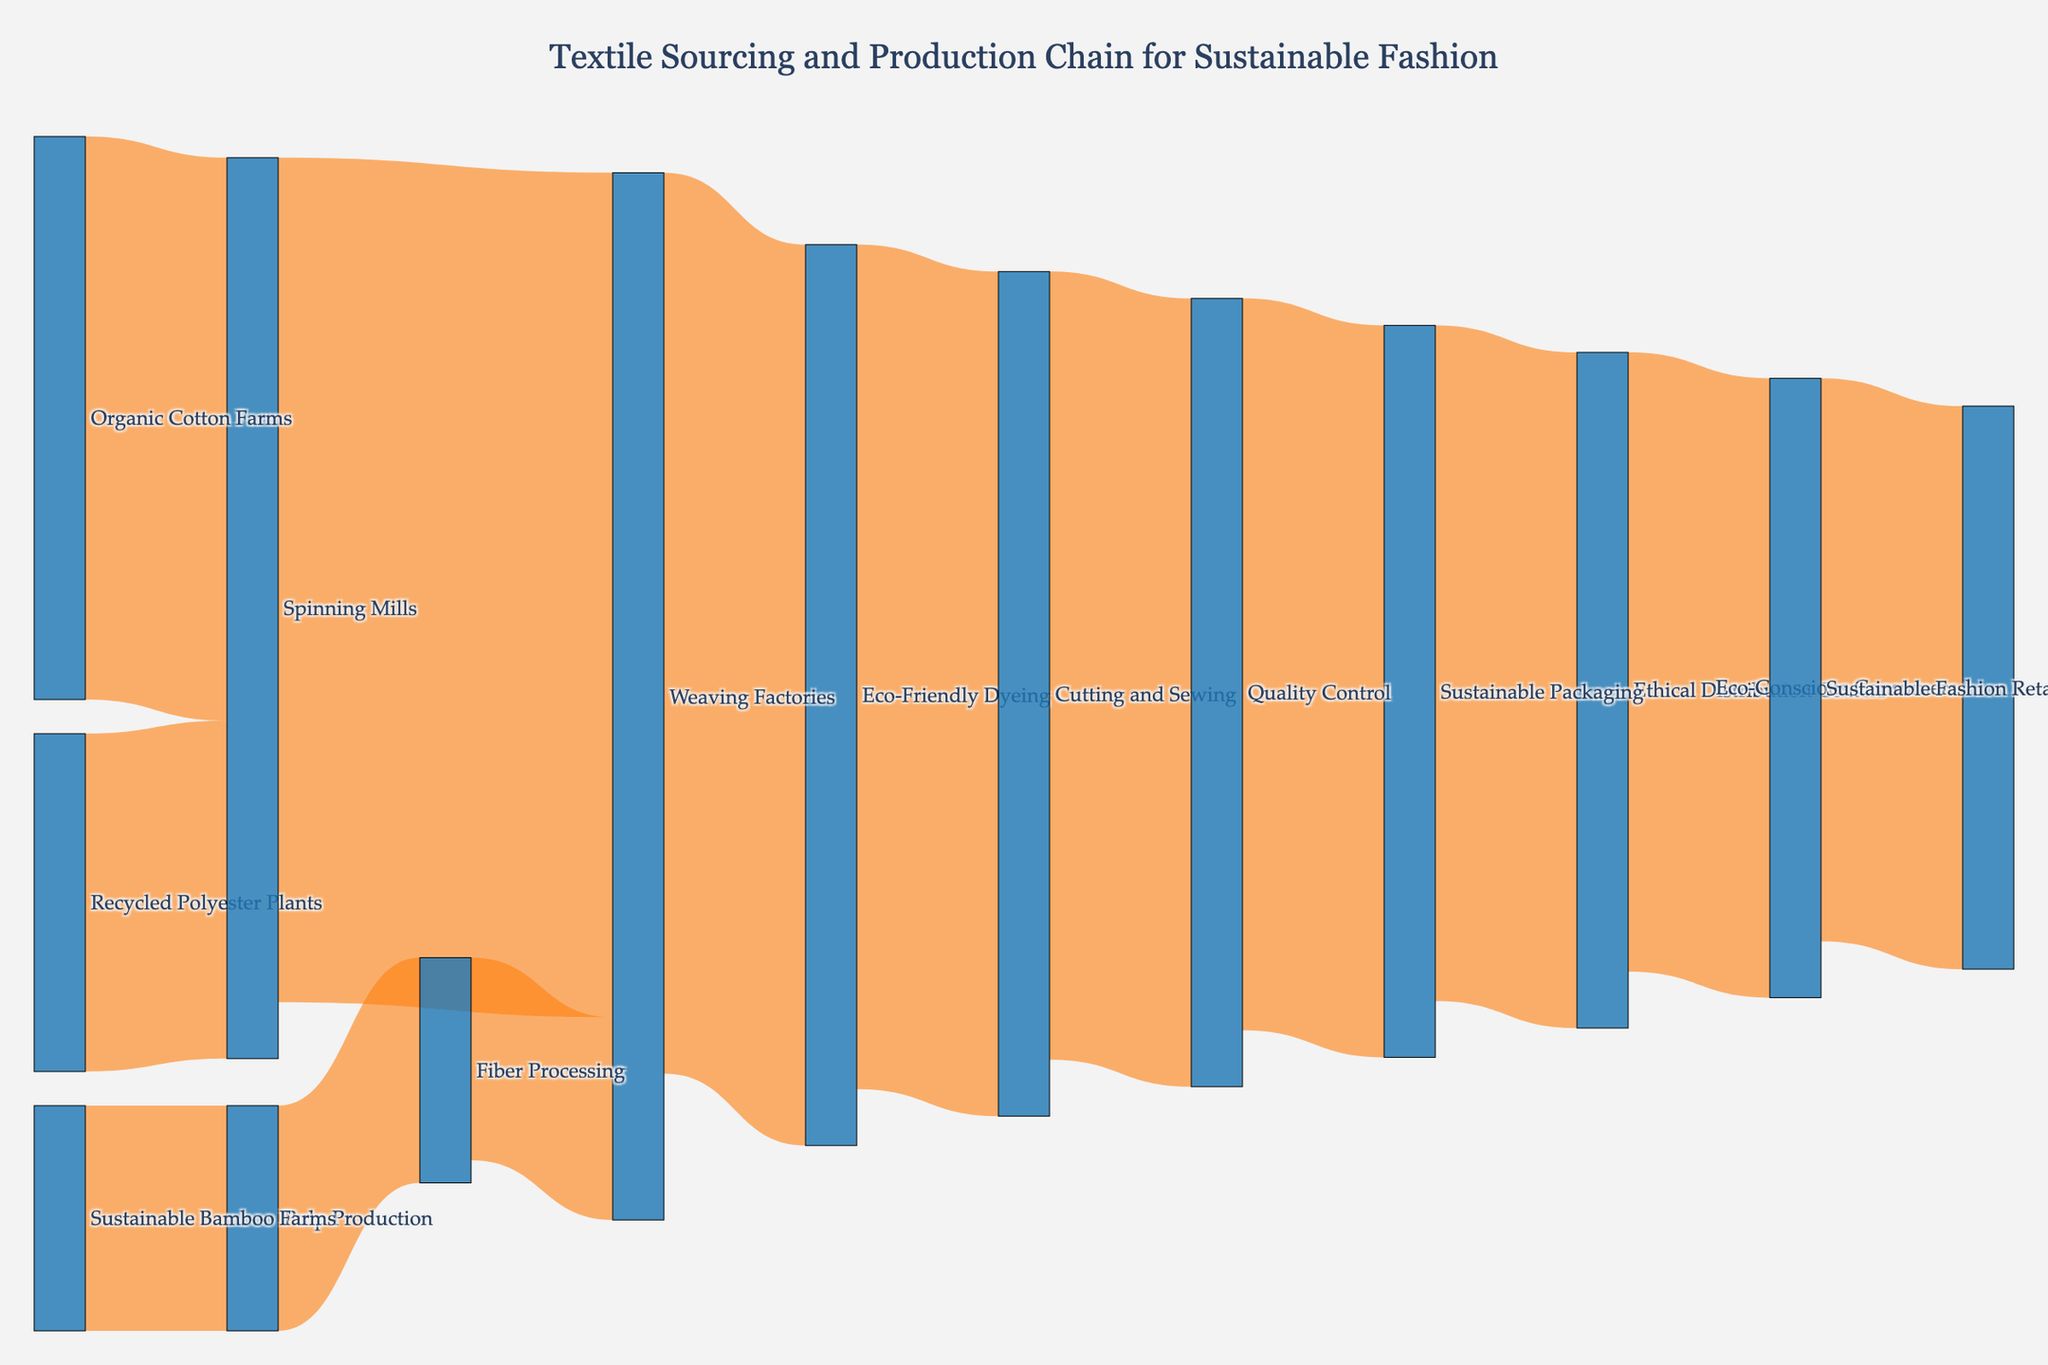Which source contributes most to the Spinning Mills? First, identify the sources connecting to Spinning Mills. Organic Cotton Farms and Recycled Polyester Plants both lead to Spinning Mills. Compare their values: 5000 for Organic Cotton Farms and 3000 for Recycled Polyester Plants. Since 5000 is greater than 3000, Organic Cotton Farms contributes the most.
Answer: Organic Cotton Farms What's the total value of materials handled by Weaving Factories? Identify all sources and targets connected to Weaving Factories. Spinning Mills contribute 7500, and Fiber Processing adds 1800. Sum these values: 7500 + 1800 = 9300. Thus, the total value is 9300.
Answer: 9300 How many distinct stages are there in the production chain? Count each unique node (stage) in the diagram: Organic Cotton Farms, Recycled Polyester Plants, Sustainable Bamboo Farms, Spinning Mills, Pulp Production, Fiber Processing, Weaving Factories, Eco-Friendly Dyeing, Cutting and Sewing, Quality Control, Sustainable Packaging, Ethical Distribution Centers, Sustainable Fashion Retailers, and Eco-Conscious Consumers. There are 14 distinct stages.
Answer: 14 Which process immediately follows Fiber Processing? Locate Fiber Processing as a source to identify its target. Fiber Processing leads to Weaving Factories. Therefore, Weaving Factories follow Fiber Processing.
Answer: Weaving Factories What's the average value of materials passing through the first three stages (Organic Cotton Farms, Recycled Polyester Plants, Sustainable Bamboo Farms)? Identifying the values: Organic Cotton Farms (5000), Recycled Polyester Plants (3000), and Sustainable Bamboo Farms (2000). Sum these values: 5000 + 3000 + 2000 = 10000. Divide by the number of stages (3): 10000 / 3 = 3333.33.
Answer: 3333.33 Is the value of materials from Eco-Friendly Dyeing to Cutting and Sewing greater than that from Cutting and Sewing to Quality Control? The value from Eco-Friendly Dyeing to Cutting and Sewing is 7500. The value from Cutting and Sewing to Quality Control is 7000. Comparing these values, 7500 is greater than 7000.
Answer: Yes Which stage has the smallest inflow of materials in the production chain? Find the stages and their inflow values: Spinning Mills (8000 = 5000 + 3000), Weaving Factories (9300 = 7500 + 1800), Eco-Friendly Dyeing (8000), Cutting and Sewing (7500), Quality Control (7000), Sustainable Packaging (6500), Ethical Distribution Centers (6000), Sustainable Fashion Retailers (5500), Eco-Conscious Consumers (5000). Sustainable Bamboo Farms and Fiber Processing have 2000 each. The smallest inflow value is 2000.
Answer: Fiber Processing What is the final stage in the sustainable fashion production chain? Trace the flow from the beginning stages through each successive stage to the final target. The last target is Eco-Conscious Consumers.
Answer: Eco-Conscious Consumers What is the difference in value between Sustainable Packaging and Ethical Distribution Centers? The value for Sustainable Packaging is 6500, and the value for Ethical Distribution Centers is 6000. Subtract the smaller value from the larger: 6500 - 6000 = 500.
Answer: 500 